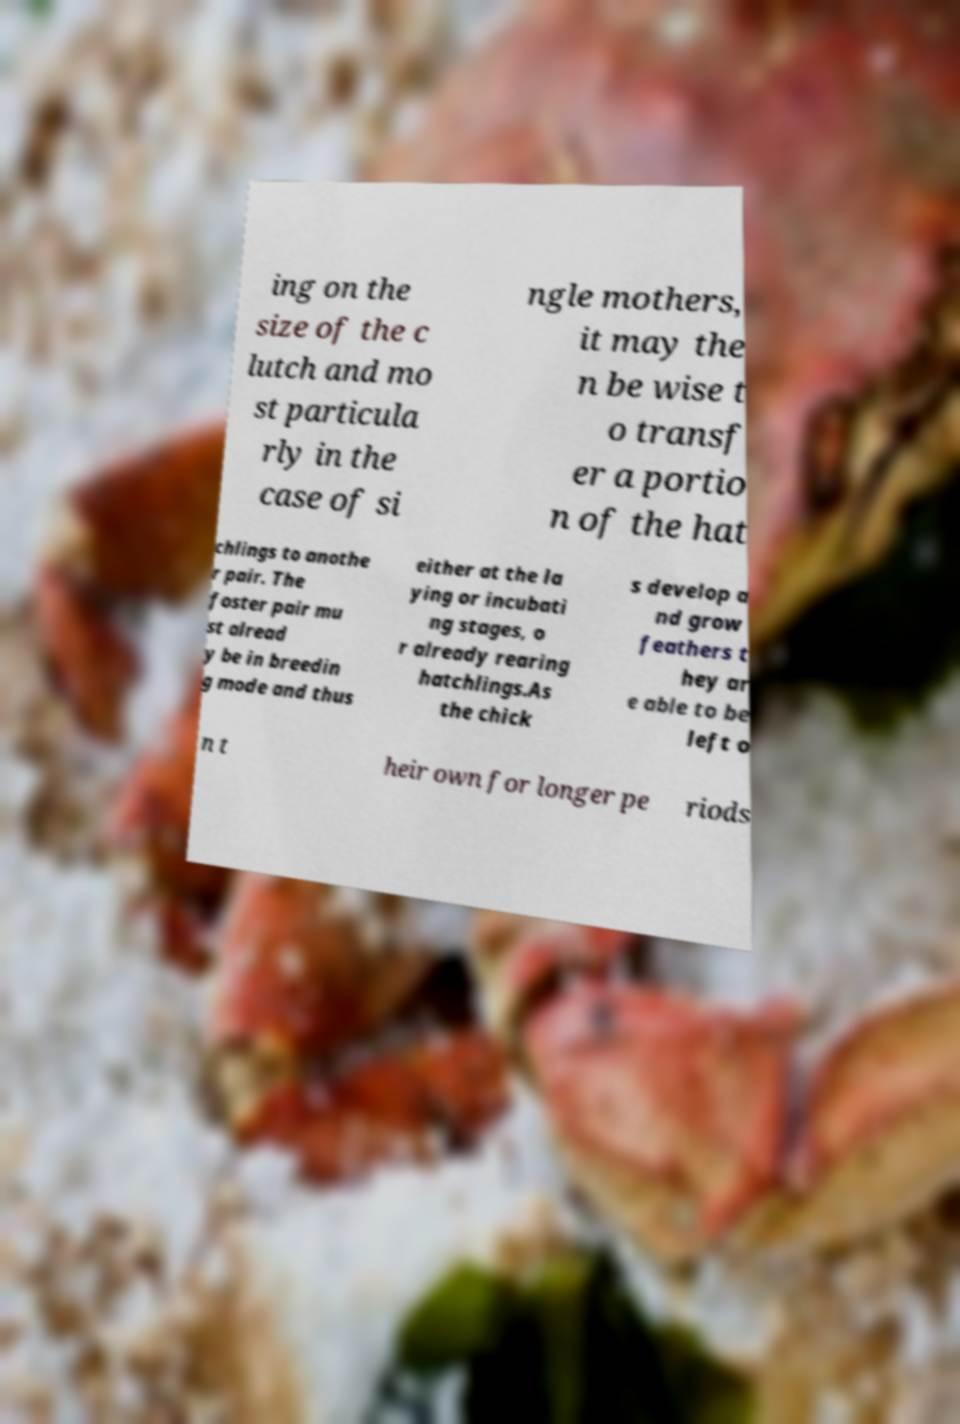Please identify and transcribe the text found in this image. ing on the size of the c lutch and mo st particula rly in the case of si ngle mothers, it may the n be wise t o transf er a portio n of the hat chlings to anothe r pair. The foster pair mu st alread y be in breedin g mode and thus either at the la ying or incubati ng stages, o r already rearing hatchlings.As the chick s develop a nd grow feathers t hey ar e able to be left o n t heir own for longer pe riods 